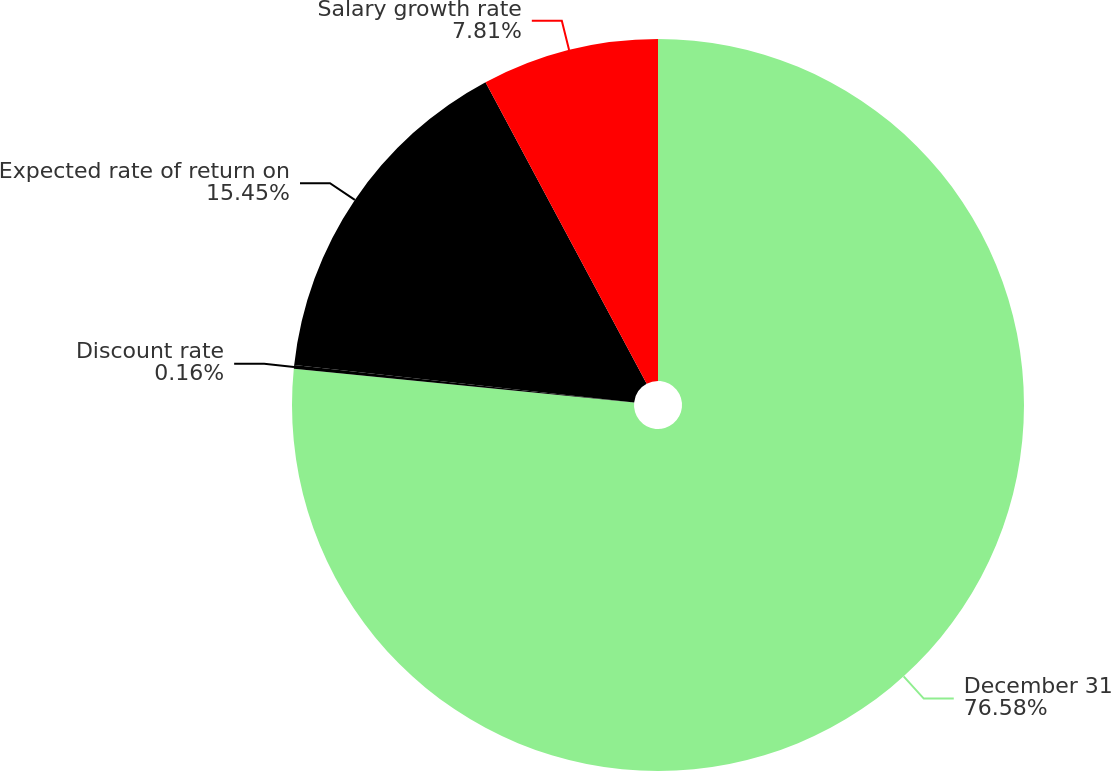Convert chart to OTSL. <chart><loc_0><loc_0><loc_500><loc_500><pie_chart><fcel>December 31<fcel>Discount rate<fcel>Expected rate of return on<fcel>Salary growth rate<nl><fcel>76.58%<fcel>0.16%<fcel>15.45%<fcel>7.81%<nl></chart> 